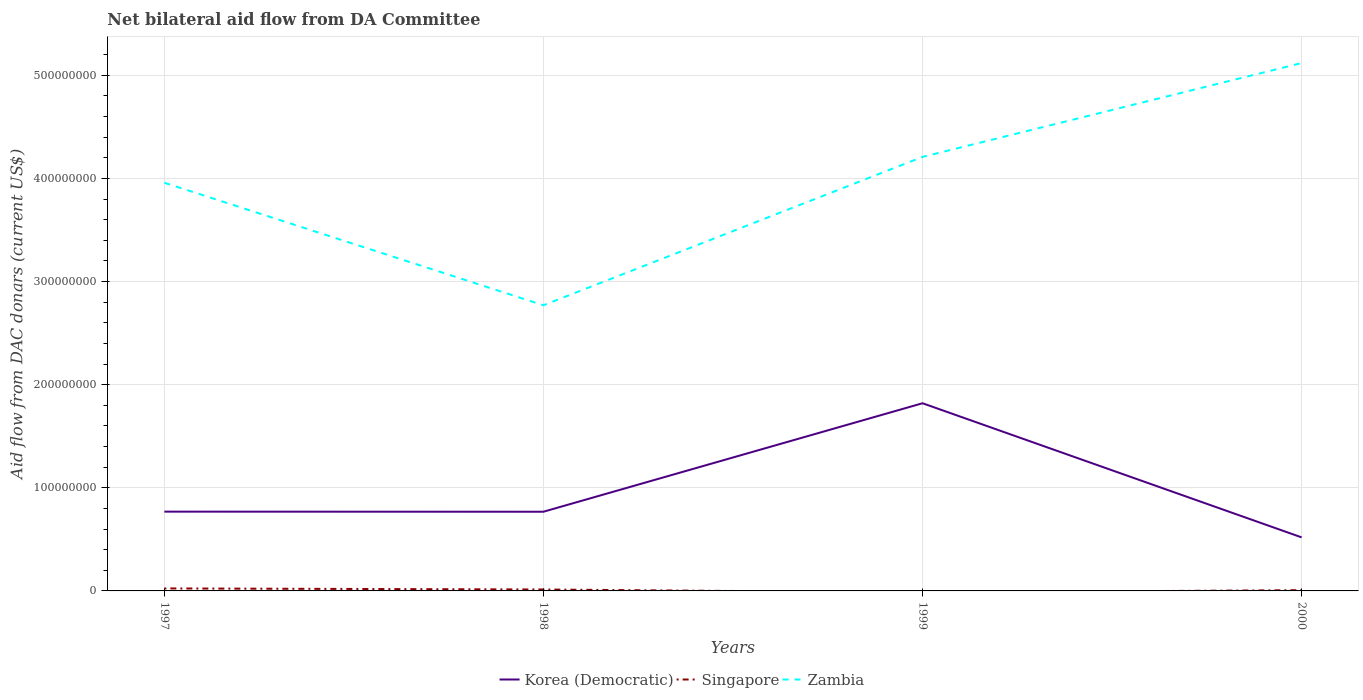How many different coloured lines are there?
Offer a very short reply. 3. Does the line corresponding to Korea (Democratic) intersect with the line corresponding to Zambia?
Make the answer very short. No. Across all years, what is the maximum aid flow in in Singapore?
Keep it short and to the point. 0. What is the total aid flow in in Korea (Democratic) in the graph?
Give a very brief answer. -1.05e+08. What is the difference between the highest and the second highest aid flow in in Korea (Democratic)?
Offer a terse response. 1.30e+08. Is the aid flow in in Singapore strictly greater than the aid flow in in Zambia over the years?
Make the answer very short. Yes. How many lines are there?
Make the answer very short. 3. How many years are there in the graph?
Your response must be concise. 4. Are the values on the major ticks of Y-axis written in scientific E-notation?
Your answer should be very brief. No. Does the graph contain any zero values?
Your answer should be very brief. Yes. What is the title of the graph?
Provide a short and direct response. Net bilateral aid flow from DA Committee. Does "Libya" appear as one of the legend labels in the graph?
Keep it short and to the point. No. What is the label or title of the Y-axis?
Offer a very short reply. Aid flow from DAC donars (current US$). What is the Aid flow from DAC donars (current US$) of Korea (Democratic) in 1997?
Your answer should be compact. 7.69e+07. What is the Aid flow from DAC donars (current US$) of Singapore in 1997?
Keep it short and to the point. 2.42e+06. What is the Aid flow from DAC donars (current US$) of Zambia in 1997?
Ensure brevity in your answer.  3.96e+08. What is the Aid flow from DAC donars (current US$) of Korea (Democratic) in 1998?
Keep it short and to the point. 7.68e+07. What is the Aid flow from DAC donars (current US$) in Singapore in 1998?
Ensure brevity in your answer.  1.38e+06. What is the Aid flow from DAC donars (current US$) of Zambia in 1998?
Provide a succinct answer. 2.77e+08. What is the Aid flow from DAC donars (current US$) in Korea (Democratic) in 1999?
Keep it short and to the point. 1.82e+08. What is the Aid flow from DAC donars (current US$) in Zambia in 1999?
Your response must be concise. 4.21e+08. What is the Aid flow from DAC donars (current US$) of Korea (Democratic) in 2000?
Provide a short and direct response. 5.19e+07. What is the Aid flow from DAC donars (current US$) in Singapore in 2000?
Ensure brevity in your answer.  7.30e+05. What is the Aid flow from DAC donars (current US$) of Zambia in 2000?
Make the answer very short. 5.12e+08. Across all years, what is the maximum Aid flow from DAC donars (current US$) in Korea (Democratic)?
Your answer should be very brief. 1.82e+08. Across all years, what is the maximum Aid flow from DAC donars (current US$) of Singapore?
Give a very brief answer. 2.42e+06. Across all years, what is the maximum Aid flow from DAC donars (current US$) in Zambia?
Ensure brevity in your answer.  5.12e+08. Across all years, what is the minimum Aid flow from DAC donars (current US$) of Korea (Democratic)?
Your response must be concise. 5.19e+07. Across all years, what is the minimum Aid flow from DAC donars (current US$) in Zambia?
Make the answer very short. 2.77e+08. What is the total Aid flow from DAC donars (current US$) of Korea (Democratic) in the graph?
Keep it short and to the point. 3.88e+08. What is the total Aid flow from DAC donars (current US$) of Singapore in the graph?
Your answer should be very brief. 4.53e+06. What is the total Aid flow from DAC donars (current US$) of Zambia in the graph?
Offer a very short reply. 1.61e+09. What is the difference between the Aid flow from DAC donars (current US$) in Singapore in 1997 and that in 1998?
Your answer should be compact. 1.04e+06. What is the difference between the Aid flow from DAC donars (current US$) in Zambia in 1997 and that in 1998?
Your answer should be compact. 1.19e+08. What is the difference between the Aid flow from DAC donars (current US$) in Korea (Democratic) in 1997 and that in 1999?
Make the answer very short. -1.05e+08. What is the difference between the Aid flow from DAC donars (current US$) of Zambia in 1997 and that in 1999?
Offer a very short reply. -2.50e+07. What is the difference between the Aid flow from DAC donars (current US$) in Korea (Democratic) in 1997 and that in 2000?
Offer a very short reply. 2.50e+07. What is the difference between the Aid flow from DAC donars (current US$) of Singapore in 1997 and that in 2000?
Offer a terse response. 1.69e+06. What is the difference between the Aid flow from DAC donars (current US$) in Zambia in 1997 and that in 2000?
Keep it short and to the point. -1.16e+08. What is the difference between the Aid flow from DAC donars (current US$) of Korea (Democratic) in 1998 and that in 1999?
Offer a terse response. -1.05e+08. What is the difference between the Aid flow from DAC donars (current US$) of Zambia in 1998 and that in 1999?
Your response must be concise. -1.44e+08. What is the difference between the Aid flow from DAC donars (current US$) of Korea (Democratic) in 1998 and that in 2000?
Keep it short and to the point. 2.49e+07. What is the difference between the Aid flow from DAC donars (current US$) of Singapore in 1998 and that in 2000?
Provide a short and direct response. 6.50e+05. What is the difference between the Aid flow from DAC donars (current US$) of Zambia in 1998 and that in 2000?
Your answer should be very brief. -2.35e+08. What is the difference between the Aid flow from DAC donars (current US$) in Korea (Democratic) in 1999 and that in 2000?
Your response must be concise. 1.30e+08. What is the difference between the Aid flow from DAC donars (current US$) of Zambia in 1999 and that in 2000?
Offer a terse response. -9.10e+07. What is the difference between the Aid flow from DAC donars (current US$) of Korea (Democratic) in 1997 and the Aid flow from DAC donars (current US$) of Singapore in 1998?
Offer a very short reply. 7.55e+07. What is the difference between the Aid flow from DAC donars (current US$) of Korea (Democratic) in 1997 and the Aid flow from DAC donars (current US$) of Zambia in 1998?
Your answer should be compact. -2.00e+08. What is the difference between the Aid flow from DAC donars (current US$) in Singapore in 1997 and the Aid flow from DAC donars (current US$) in Zambia in 1998?
Offer a terse response. -2.75e+08. What is the difference between the Aid flow from DAC donars (current US$) in Korea (Democratic) in 1997 and the Aid flow from DAC donars (current US$) in Zambia in 1999?
Make the answer very short. -3.44e+08. What is the difference between the Aid flow from DAC donars (current US$) of Singapore in 1997 and the Aid flow from DAC donars (current US$) of Zambia in 1999?
Give a very brief answer. -4.18e+08. What is the difference between the Aid flow from DAC donars (current US$) in Korea (Democratic) in 1997 and the Aid flow from DAC donars (current US$) in Singapore in 2000?
Offer a very short reply. 7.62e+07. What is the difference between the Aid flow from DAC donars (current US$) of Korea (Democratic) in 1997 and the Aid flow from DAC donars (current US$) of Zambia in 2000?
Your answer should be very brief. -4.35e+08. What is the difference between the Aid flow from DAC donars (current US$) in Singapore in 1997 and the Aid flow from DAC donars (current US$) in Zambia in 2000?
Offer a very short reply. -5.10e+08. What is the difference between the Aid flow from DAC donars (current US$) of Korea (Democratic) in 1998 and the Aid flow from DAC donars (current US$) of Zambia in 1999?
Ensure brevity in your answer.  -3.44e+08. What is the difference between the Aid flow from DAC donars (current US$) in Singapore in 1998 and the Aid flow from DAC donars (current US$) in Zambia in 1999?
Your answer should be very brief. -4.20e+08. What is the difference between the Aid flow from DAC donars (current US$) of Korea (Democratic) in 1998 and the Aid flow from DAC donars (current US$) of Singapore in 2000?
Provide a short and direct response. 7.61e+07. What is the difference between the Aid flow from DAC donars (current US$) in Korea (Democratic) in 1998 and the Aid flow from DAC donars (current US$) in Zambia in 2000?
Offer a terse response. -4.35e+08. What is the difference between the Aid flow from DAC donars (current US$) in Singapore in 1998 and the Aid flow from DAC donars (current US$) in Zambia in 2000?
Ensure brevity in your answer.  -5.11e+08. What is the difference between the Aid flow from DAC donars (current US$) in Korea (Democratic) in 1999 and the Aid flow from DAC donars (current US$) in Singapore in 2000?
Offer a very short reply. 1.81e+08. What is the difference between the Aid flow from DAC donars (current US$) in Korea (Democratic) in 1999 and the Aid flow from DAC donars (current US$) in Zambia in 2000?
Provide a succinct answer. -3.30e+08. What is the average Aid flow from DAC donars (current US$) of Korea (Democratic) per year?
Your answer should be compact. 9.69e+07. What is the average Aid flow from DAC donars (current US$) in Singapore per year?
Your response must be concise. 1.13e+06. What is the average Aid flow from DAC donars (current US$) in Zambia per year?
Provide a succinct answer. 4.01e+08. In the year 1997, what is the difference between the Aid flow from DAC donars (current US$) in Korea (Democratic) and Aid flow from DAC donars (current US$) in Singapore?
Offer a terse response. 7.45e+07. In the year 1997, what is the difference between the Aid flow from DAC donars (current US$) of Korea (Democratic) and Aid flow from DAC donars (current US$) of Zambia?
Keep it short and to the point. -3.19e+08. In the year 1997, what is the difference between the Aid flow from DAC donars (current US$) in Singapore and Aid flow from DAC donars (current US$) in Zambia?
Give a very brief answer. -3.93e+08. In the year 1998, what is the difference between the Aid flow from DAC donars (current US$) of Korea (Democratic) and Aid flow from DAC donars (current US$) of Singapore?
Keep it short and to the point. 7.54e+07. In the year 1998, what is the difference between the Aid flow from DAC donars (current US$) of Korea (Democratic) and Aid flow from DAC donars (current US$) of Zambia?
Your answer should be compact. -2.00e+08. In the year 1998, what is the difference between the Aid flow from DAC donars (current US$) of Singapore and Aid flow from DAC donars (current US$) of Zambia?
Offer a very short reply. -2.76e+08. In the year 1999, what is the difference between the Aid flow from DAC donars (current US$) in Korea (Democratic) and Aid flow from DAC donars (current US$) in Zambia?
Give a very brief answer. -2.39e+08. In the year 2000, what is the difference between the Aid flow from DAC donars (current US$) of Korea (Democratic) and Aid flow from DAC donars (current US$) of Singapore?
Your response must be concise. 5.12e+07. In the year 2000, what is the difference between the Aid flow from DAC donars (current US$) in Korea (Democratic) and Aid flow from DAC donars (current US$) in Zambia?
Your answer should be compact. -4.60e+08. In the year 2000, what is the difference between the Aid flow from DAC donars (current US$) of Singapore and Aid flow from DAC donars (current US$) of Zambia?
Ensure brevity in your answer.  -5.11e+08. What is the ratio of the Aid flow from DAC donars (current US$) in Singapore in 1997 to that in 1998?
Offer a very short reply. 1.75. What is the ratio of the Aid flow from DAC donars (current US$) of Zambia in 1997 to that in 1998?
Offer a terse response. 1.43. What is the ratio of the Aid flow from DAC donars (current US$) of Korea (Democratic) in 1997 to that in 1999?
Your answer should be very brief. 0.42. What is the ratio of the Aid flow from DAC donars (current US$) of Zambia in 1997 to that in 1999?
Offer a terse response. 0.94. What is the ratio of the Aid flow from DAC donars (current US$) in Korea (Democratic) in 1997 to that in 2000?
Your response must be concise. 1.48. What is the ratio of the Aid flow from DAC donars (current US$) in Singapore in 1997 to that in 2000?
Ensure brevity in your answer.  3.32. What is the ratio of the Aid flow from DAC donars (current US$) in Zambia in 1997 to that in 2000?
Your answer should be very brief. 0.77. What is the ratio of the Aid flow from DAC donars (current US$) of Korea (Democratic) in 1998 to that in 1999?
Give a very brief answer. 0.42. What is the ratio of the Aid flow from DAC donars (current US$) in Zambia in 1998 to that in 1999?
Your answer should be compact. 0.66. What is the ratio of the Aid flow from DAC donars (current US$) of Korea (Democratic) in 1998 to that in 2000?
Keep it short and to the point. 1.48. What is the ratio of the Aid flow from DAC donars (current US$) of Singapore in 1998 to that in 2000?
Your response must be concise. 1.89. What is the ratio of the Aid flow from DAC donars (current US$) of Zambia in 1998 to that in 2000?
Keep it short and to the point. 0.54. What is the ratio of the Aid flow from DAC donars (current US$) in Korea (Democratic) in 1999 to that in 2000?
Give a very brief answer. 3.5. What is the ratio of the Aid flow from DAC donars (current US$) of Zambia in 1999 to that in 2000?
Give a very brief answer. 0.82. What is the difference between the highest and the second highest Aid flow from DAC donars (current US$) of Korea (Democratic)?
Your answer should be very brief. 1.05e+08. What is the difference between the highest and the second highest Aid flow from DAC donars (current US$) of Singapore?
Offer a terse response. 1.04e+06. What is the difference between the highest and the second highest Aid flow from DAC donars (current US$) in Zambia?
Ensure brevity in your answer.  9.10e+07. What is the difference between the highest and the lowest Aid flow from DAC donars (current US$) in Korea (Democratic)?
Your answer should be compact. 1.30e+08. What is the difference between the highest and the lowest Aid flow from DAC donars (current US$) in Singapore?
Your response must be concise. 2.42e+06. What is the difference between the highest and the lowest Aid flow from DAC donars (current US$) of Zambia?
Provide a succinct answer. 2.35e+08. 